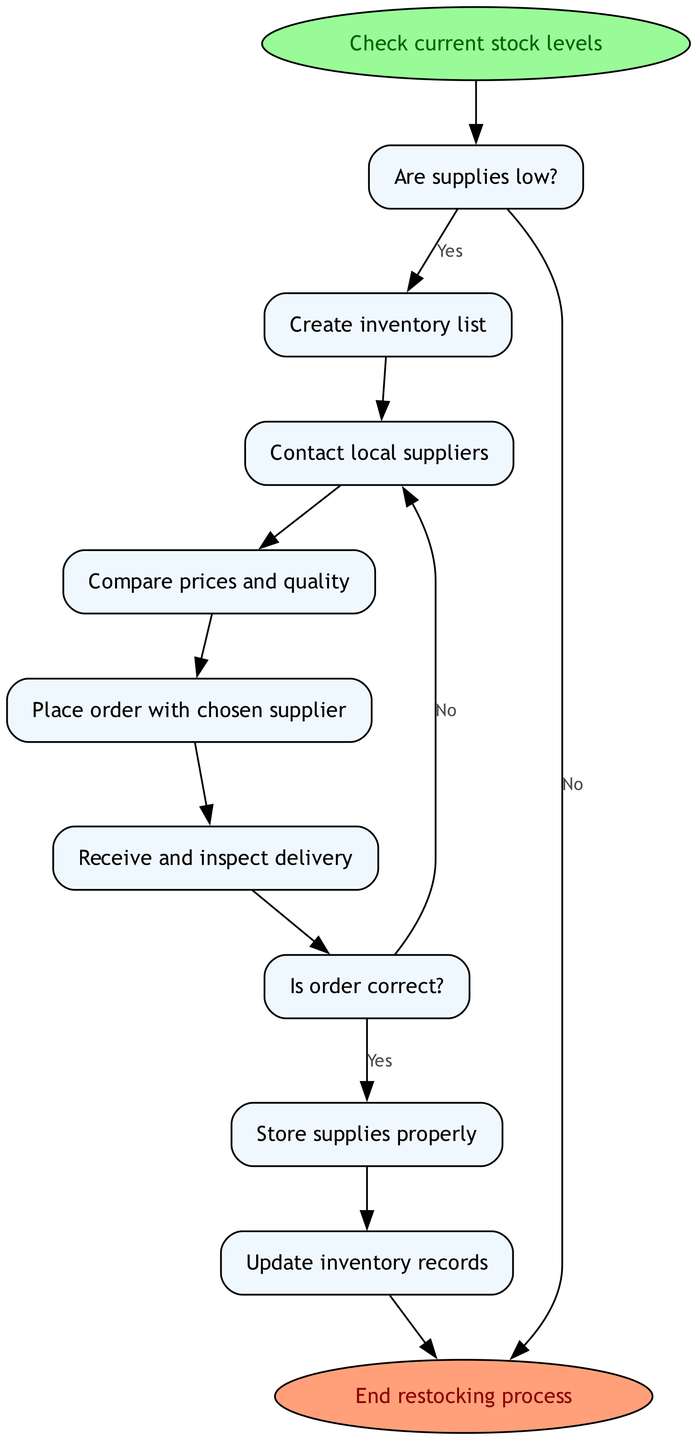What is the first step in the restocking process? The first step in the flow chart is "Check current stock levels," which indicates that the process starts with reviewing what supplies are currently available.
Answer: Check current stock levels How many decision nodes are in the diagram? The diagram contains two decision nodes: "Are supplies low?" and "Is order correct?" These are critical points where a choice is made that affects the next steps.
Answer: 2 What happens if supplies are not low? If supplies are not low, the flow moves directly to the end of the process, indicating that no further action is needed for restocking at that time.
Answer: End restocking process After creating the inventory list, which step follows? The step that follows "Create inventory list" is "Contact local suppliers," which involves reaching out to suppliers to assess availability and pricing.
Answer: Contact local suppliers What action is taken if the order is not correct? If the order is not correct, the process returns to "Contact local suppliers," indicating that the issue must be resolved before proceeding with the restocking.
Answer: Contact local suppliers Which step comes directly before updating inventory records? The step that comes directly before "Update inventory records" is "Store supplies properly," ensuring that all new supplies are stored correctly before recording them.
Answer: Store supplies properly How many processes are involved in this flow chart? The flow chart consists of five process nodes: "Create inventory list," "Contact local suppliers," "Compare prices and quality," "Place order with chosen supplier," "Receive and inspect delivery," "Store supplies properly," and "Update inventory records."
Answer: 7 What is the last step of the restocking process? The final step in the diagram is "End restocking process," indicating the conclusion of the supply chain management procedure once all previous steps are completed.
Answer: End restocking process 